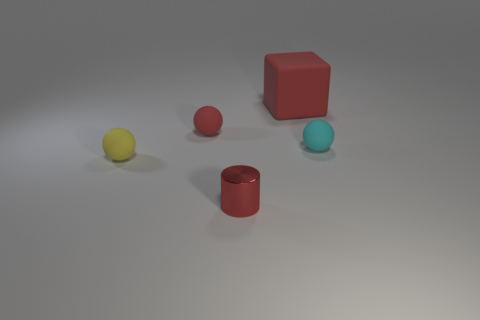The other big object that is made of the same material as the yellow object is what color?
Offer a very short reply. Red. There is a small metal object; is its color the same as the matte ball that is right of the red block?
Your response must be concise. No. What color is the tiny rubber thing that is to the left of the big thing and behind the small yellow sphere?
Your answer should be compact. Red. How many tiny matte spheres are right of the metallic cylinder?
Ensure brevity in your answer.  1. What number of things are blue cylinders or small red things that are behind the small yellow matte ball?
Give a very brief answer. 1. Are there any cubes on the left side of the red rubber object that is to the left of the big block?
Offer a very short reply. No. There is a matte ball that is in front of the cyan ball; what color is it?
Offer a very short reply. Yellow. Are there an equal number of balls that are to the left of the tiny red metallic object and yellow rubber objects?
Provide a succinct answer. No. There is a red thing that is both behind the small red shiny cylinder and on the left side of the large red rubber object; what is its shape?
Make the answer very short. Sphere. Is there any other thing of the same color as the shiny cylinder?
Make the answer very short. Yes. 